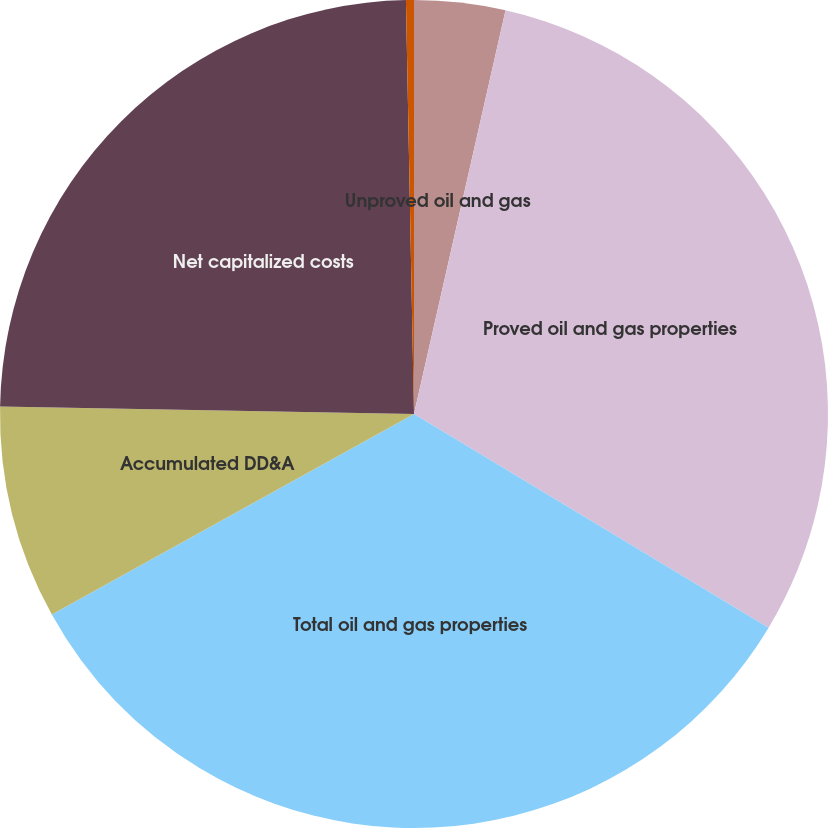<chart> <loc_0><loc_0><loc_500><loc_500><pie_chart><fcel>Unproved oil and gas<fcel>Proved oil and gas properties<fcel>Total oil and gas properties<fcel>Accumulated DD&A<fcel>Net capitalized costs<fcel>Our share of Alba Plant net<nl><fcel>3.55%<fcel>30.08%<fcel>33.32%<fcel>8.34%<fcel>24.4%<fcel>0.31%<nl></chart> 